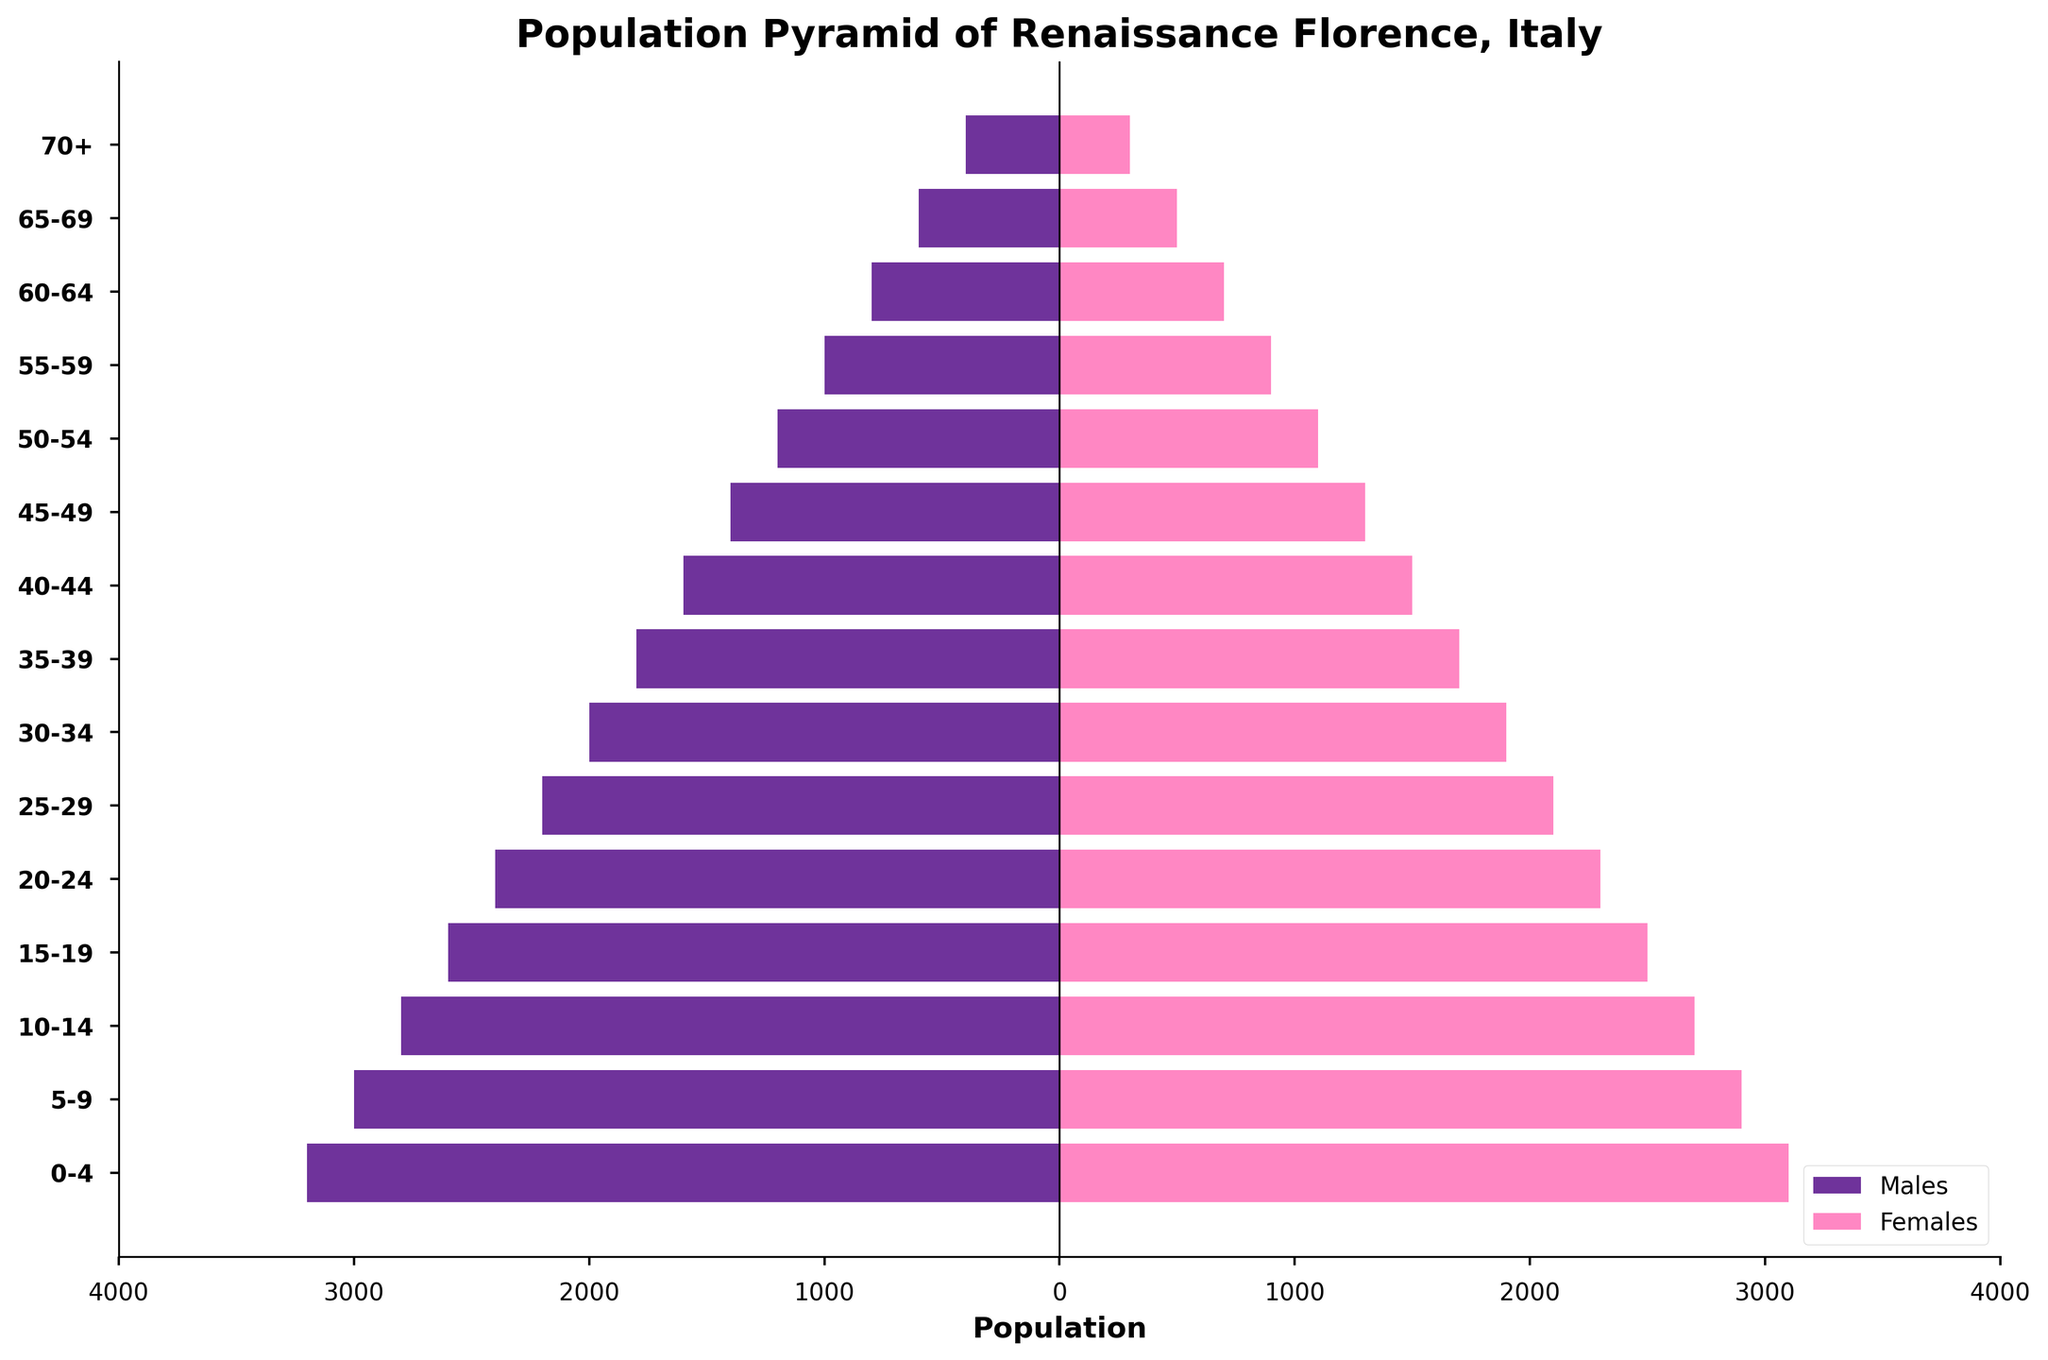What are the colors used for representing males and females on the population pyramid? The bars for males are color-coded in purple, and the bars for females are color-coded in pink.
Answer: Purple for males, pink for females What is the population of females in the age group 15-19? Refer to the bar corresponding to the age group 15-19 for females, which displays the population as 2500.
Answer: 2500 How does the population of males and females compare in the age group 40-44? The bar for males in the 40-44 age group is 1600, and the bar for females is 1500.
Answer: Males: 1600, Females: 1500 Which age group has the smallest population, and what is the total for both genders? The age group 70+ has the smallest population with 400 males and 300 females. The total is 700.
Answer: 70+, total 700 What is the difference in population between males and females in the age group 25-29? For the age group 25-29, the male population is 2200 and the female population is 2100. Subtract 2100 from 2200 to find the difference, which is 100.
Answer: 100 Which age group has the highest overall population, and what are the specific values for males and females? The age group 0-4 has the highest overall population. Males are 3200 and females are 3100, making a total of 6300.
Answer: 0-4, 3200 males, 3100 females What is the total population of all males depicted on the pyramid? Summing all male populations: 3200 + 3000 + 2800 + 2600 + 2400 + 2200 + 2000 + 1800 + 1600 + 1400 + 1200 + 1000 + 800 + 600 + 400 equals 29400.
Answer: 29400 In which age group is the gender ratio most balanced, and what is the ratio for that group? For age group 30-34, males are 2000 and females are 1900. The ratio of males to females is 2000:1900, which simplifies to approximately 1.05:1.
Answer: 30-34, 1.05:1 How many age groups depict males having a higher population than females? By examining each age group, count the instances where the male bar is longer than the female bar: 0-4, 5-9, 10-14, 15-19, 20-24, 25-29, 30-34, 35-39, 40-44, 45-49, 50-54, 55-59. There are 12 such age groups.
Answer: 12 